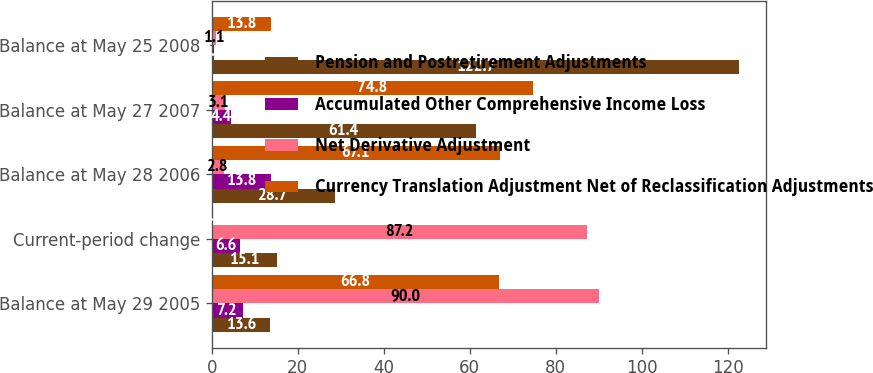Convert chart. <chart><loc_0><loc_0><loc_500><loc_500><stacked_bar_chart><ecel><fcel>Balance at May 29 2005<fcel>Current-period change<fcel>Balance at May 28 2006<fcel>Balance at May 27 2007<fcel>Balance at May 25 2008<nl><fcel>Pension and Postretirement Adjustments<fcel>13.6<fcel>15.1<fcel>28.7<fcel>61.4<fcel>122.7<nl><fcel>Accumulated Other Comprehensive Income Loss<fcel>7.2<fcel>6.6<fcel>13.8<fcel>4.4<fcel>0.5<nl><fcel>Net Derivative Adjustment<fcel>90<fcel>87.2<fcel>2.8<fcel>3.1<fcel>1.1<nl><fcel>Currency Translation Adjustment Net of Reclassification Adjustments<fcel>66.8<fcel>0.3<fcel>67.1<fcel>74.8<fcel>13.8<nl></chart> 